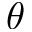Convert formula to latex. <formula><loc_0><loc_0><loc_500><loc_500>\theta</formula> 